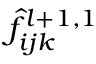Convert formula to latex. <formula><loc_0><loc_0><loc_500><loc_500>\hat { f } _ { i j k } ^ { l + 1 , 1 }</formula> 